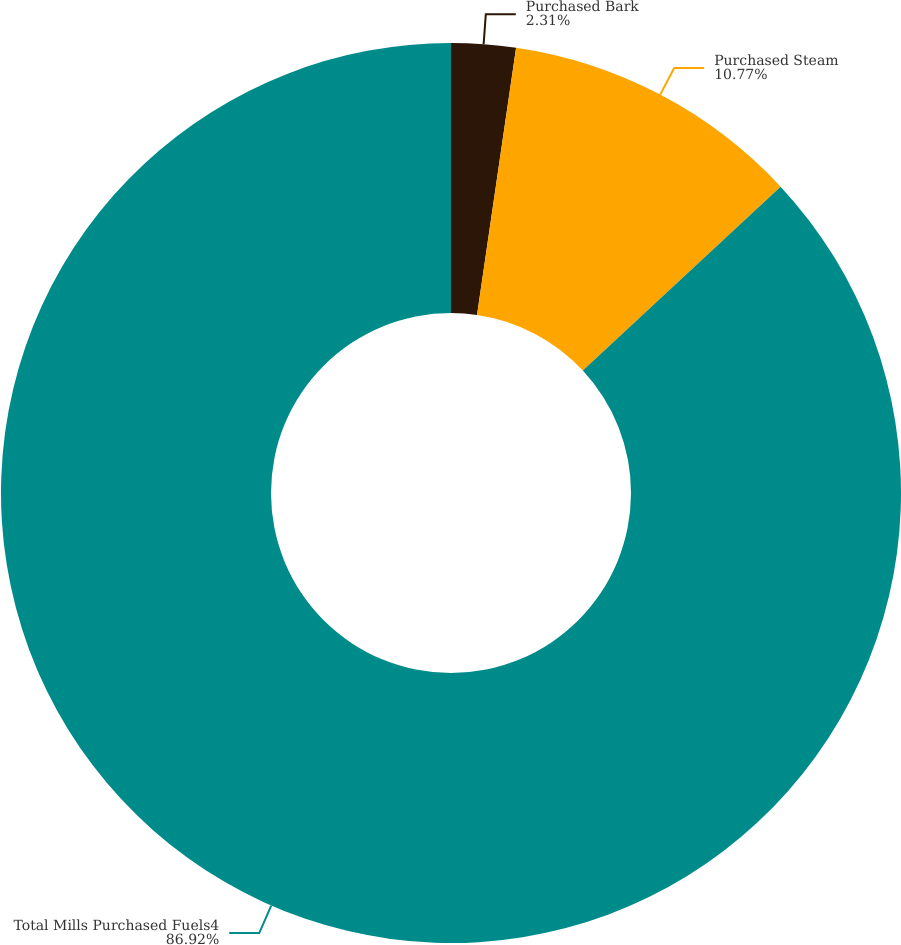<chart> <loc_0><loc_0><loc_500><loc_500><pie_chart><fcel>Purchased Bark<fcel>Purchased Steam<fcel>Total Mills Purchased Fuels4<nl><fcel>2.31%<fcel>10.77%<fcel>86.91%<nl></chart> 